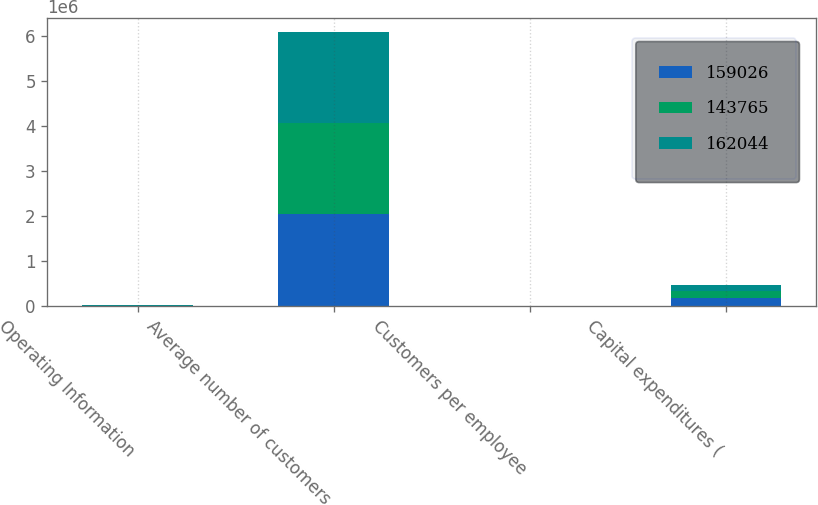<chart> <loc_0><loc_0><loc_500><loc_500><stacked_bar_chart><ecel><fcel>Operating Information<fcel>Average number of customers<fcel>Customers per employee<fcel>Capital expenditures (<nl><fcel>159026<fcel>2007<fcel>2.05077e+06<fcel>732<fcel>162044<nl><fcel>143765<fcel>2006<fcel>2.03155e+06<fcel>713<fcel>159026<nl><fcel>162044<fcel>2005<fcel>2.0189e+06<fcel>689<fcel>143765<nl></chart> 